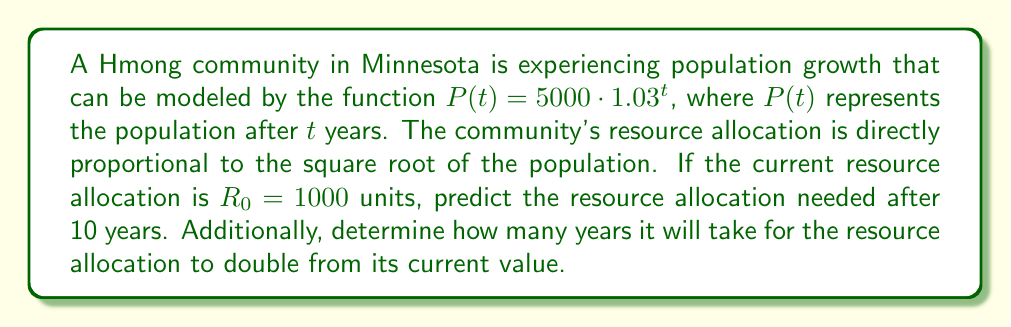Help me with this question. Let's approach this problem step by step:

1) First, we need to find the population after 10 years:
   $P(10) = 5000 \cdot 1.03^{10} = 5000 \cdot 1.3439 = 6719.58$

2) Now, we need to establish the relationship between population and resource allocation. Let $R(t)$ be the resource allocation at time $t$. We're told that $R(t)$ is directly proportional to $\sqrt{P(t)}$:
   $R(t) = k\sqrt{P(t)}$, where $k$ is a constant.

3) We can find $k$ using the initial conditions:
   $R_0 = 1000 = k\sqrt{5000}$
   $k = \frac{1000}{\sqrt{5000}} = \frac{1000}{\sqrt{5000}} = 14.14$

4) Now we can find $R(10)$:
   $R(10) = 14.14\sqrt{6719.58} = 1159.99$

5) For the second part, we need to find $t$ when $R(t) = 2R_0 = 2000$:
   $2000 = 14.14\sqrt{5000 \cdot 1.03^t}$
   $\sqrt{5000 \cdot 1.03^t} = 141.44$
   $5000 \cdot 1.03^t = 20005.28$
   $1.03^t = 4.0011$
   $t\ln(1.03) = \ln(4.0011)$
   $t = \frac{\ln(4.0011)}{\ln(1.03)} = 47.02$ years
Answer: The resource allocation needed after 10 years will be approximately 1160 units. It will take about 47 years for the resource allocation to double from its current value. 